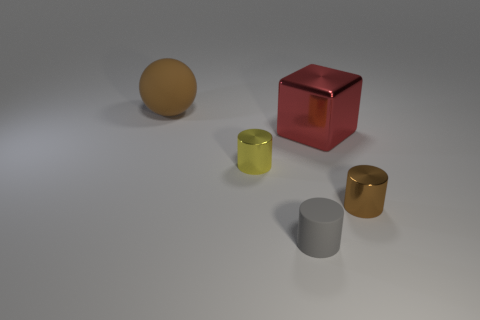Add 1 tiny brown spheres. How many objects exist? 6 Subtract all cylinders. How many objects are left? 2 Subtract all yellow shiny cylinders. Subtract all large red matte objects. How many objects are left? 4 Add 4 yellow shiny cylinders. How many yellow shiny cylinders are left? 5 Add 5 big brown matte objects. How many big brown matte objects exist? 6 Subtract 0 yellow balls. How many objects are left? 5 